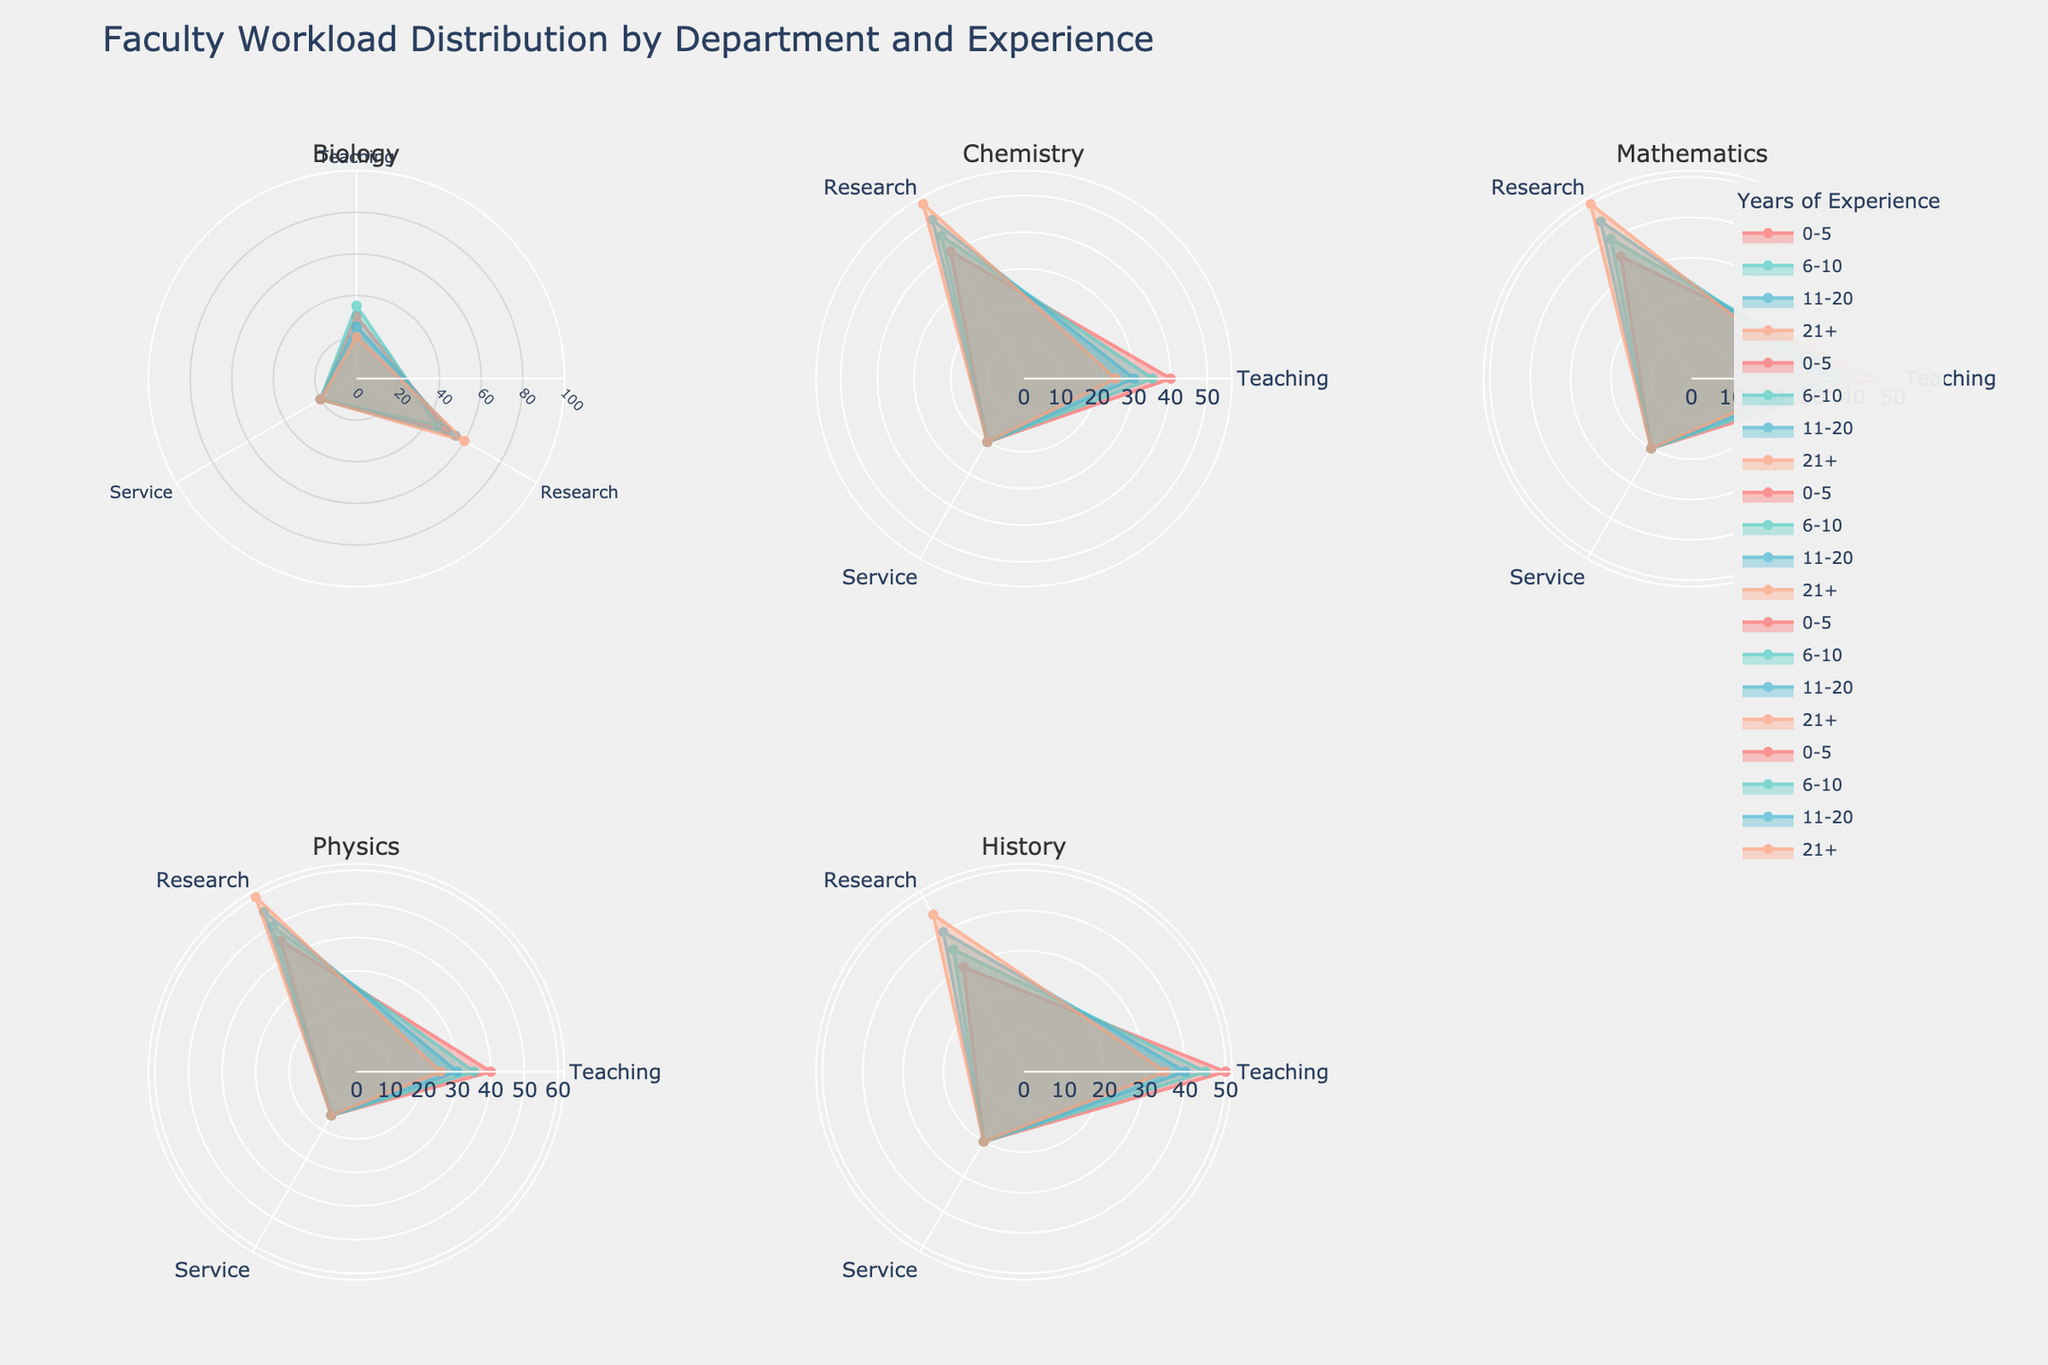Which department has the highest allocation for teaching in the 0-5 years experience group? By examining the polar chart, we can see that the History department has the highest allocation for teaching among the 0-5 years experience group.
Answer: History How does the percentage of research change in the Mathematics department from 0-5 years to 21+ years? For the Mathematics department, the percentage of research starts at 35% for the 0-5 years group and increases to 50% by the 21+ years group, showing a 15% increase.
Answer: 15% increase Which department shows the most consistent percentage for service across all experience levels? Looking at the subplots, Biology and Chemistry consistently show a 20% allocation for service across all experience levels.
Answer: Biology and Chemistry What is the combined percentage of teaching and service for the Physics department in the 11-20 years group? In the Physics department for the 11-20 years group, the percentage for teaching is 30% and for service is 15%. Combined, these add up to 30% + 15% = 45%.
Answer: 45% Compare the teaching workload between History and Physics departments for the 6-10 years experience group. Which one has a higher percentage? From the polar chart, the History department has a teaching percentage of 45% for the 6-10 years group, while the Physics department has 35%. Therefore, History has a higher percentage.
Answer: History What trend can be observed in the percentage of research for the Chemistry department as experience increases? For the Chemistry department, the research percentage starts at 40% for the 0-5 years group and increases sequentially to 45%, 50%, and 55% as experience increases. Thus, there is a clear trend of increasing research percentage with more experience.
Answer: Increasing trend Which department shows the least increase in research from 0-5 years to 21+ years of experience? The Biology department shows an increase from 50% to 60%, which is a 10% increase, the least among all other departments when comparing the same experience ranges.
Answer: Biology What's the difference between the research workload of the Biology department and Physics department in the 21+ years experience group? The research workload for Biology in the 21+ years group is 60%, while for Physics, it is also 60%, resulting in a difference of 60% - 60% = 0%.
Answer: 0% What is the average percentage of teaching across all departments for the 11-20 years experience group? The teaching percentages for the 11-20 years group are 25% (Biology), 30% (Chemistry), 35% (Mathematics), 30% (Physics), and 40% (History). The average is (25 + 30 + 35 + 30 + 40) / 5 = 32%.
Answer: 32% How does the teaching workload in the Chemistry department for the 21+ years experience level compare to the average teaching workload for the same experience level across all departments? Chemistry has a 25% teaching workload for the 21+ years level. The average teaching workload for all departments at this level is (20% + 25% + 30% + 25% + 35%) / 5 = 27%. Thus, the Chemistry department's teaching workload is 2% less than the average.
Answer: 2% less 